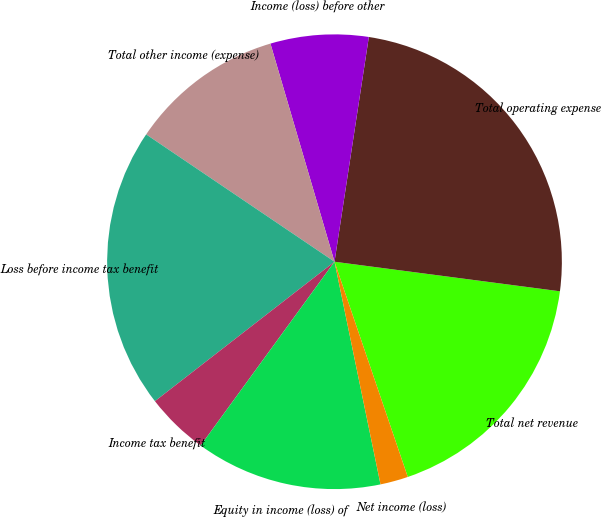<chart> <loc_0><loc_0><loc_500><loc_500><pie_chart><fcel>Total net revenue<fcel>Total operating expense<fcel>Income (loss) before other<fcel>Total other income (expense)<fcel>Loss before income tax benefit<fcel>Income tax benefit<fcel>Equity in income (loss) of<fcel>Net income (loss)<nl><fcel>17.7%<fcel>24.66%<fcel>6.96%<fcel>10.99%<fcel>19.97%<fcel>4.47%<fcel>13.26%<fcel>1.98%<nl></chart> 